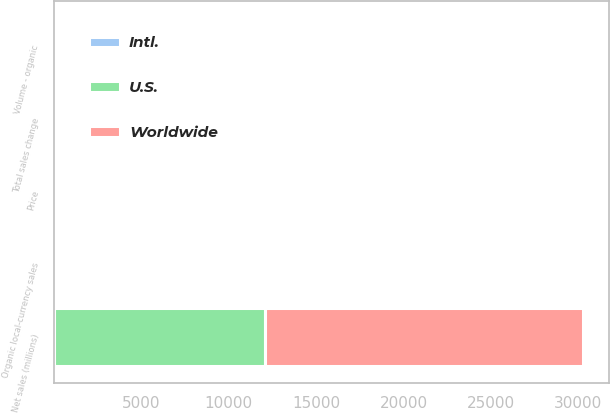<chart> <loc_0><loc_0><loc_500><loc_500><stacked_bar_chart><ecel><fcel>Net sales (millions)<fcel>Volume - organic<fcel>Price<fcel>Organic local-currency sales<fcel>Total sales change<nl><fcel>U.S.<fcel>12049<fcel>1.7<fcel>0.4<fcel>2.1<fcel>2.9<nl><fcel>Worldwide<fcel>18225<fcel>0.5<fcel>1.4<fcel>0.9<fcel>9.4<nl><fcel>Intl.<fcel>1.55<fcel>0.2<fcel>1.1<fcel>1.3<fcel>4.9<nl></chart> 